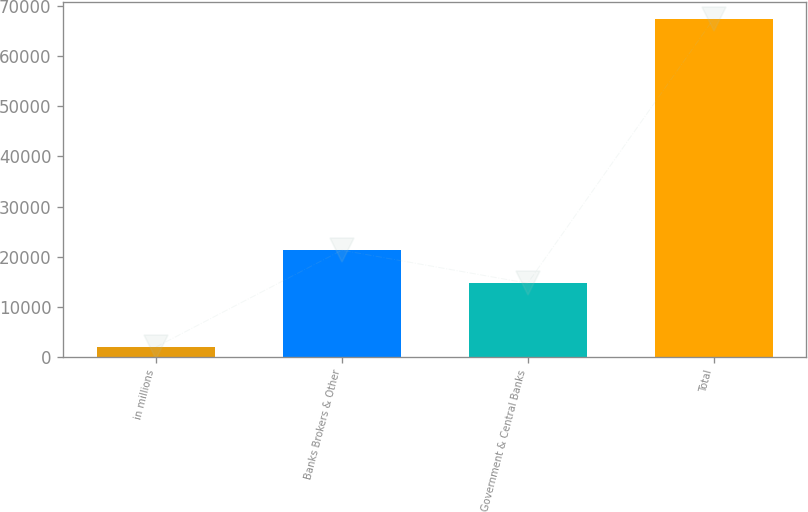<chart> <loc_0><loc_0><loc_500><loc_500><bar_chart><fcel>in millions<fcel>Banks Brokers & Other<fcel>Government & Central Banks<fcel>Total<nl><fcel>2012<fcel>21310<fcel>14729<fcel>67404<nl></chart> 